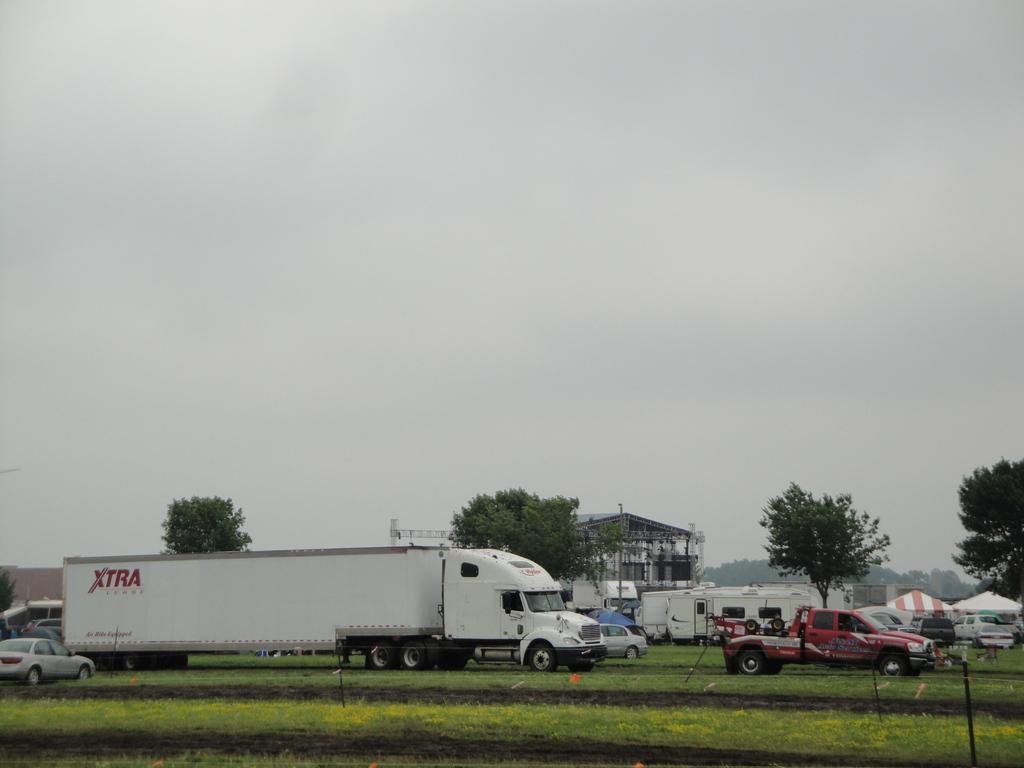Can you describe this image briefly? In this image there is a land on that land there are vehicles, in the background there are trees,shed and the sky. 